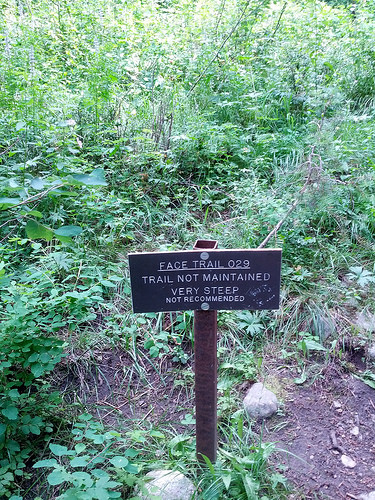<image>
Is the sign next to the tree? Yes. The sign is positioned adjacent to the tree, located nearby in the same general area. 